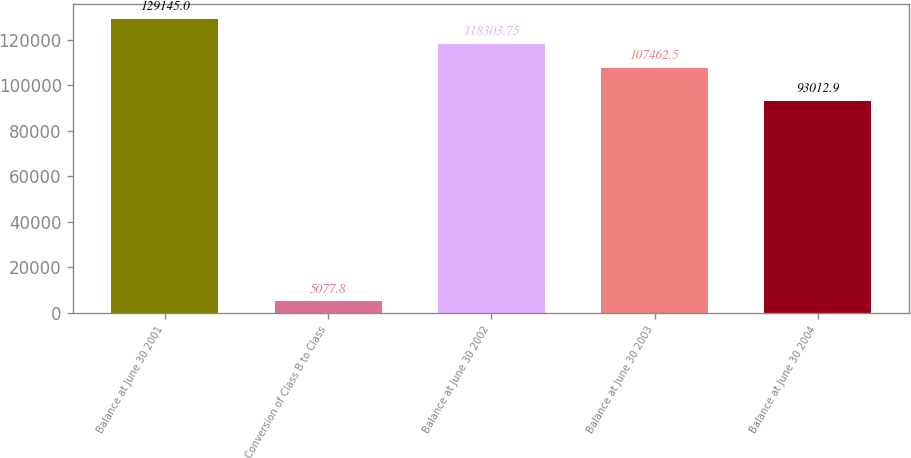<chart> <loc_0><loc_0><loc_500><loc_500><bar_chart><fcel>Balance at June 30 2001<fcel>Conversion of Class B to Class<fcel>Balance at June 30 2002<fcel>Balance at June 30 2003<fcel>Balance at June 30 2004<nl><fcel>129145<fcel>5077.8<fcel>118304<fcel>107462<fcel>93012.9<nl></chart> 